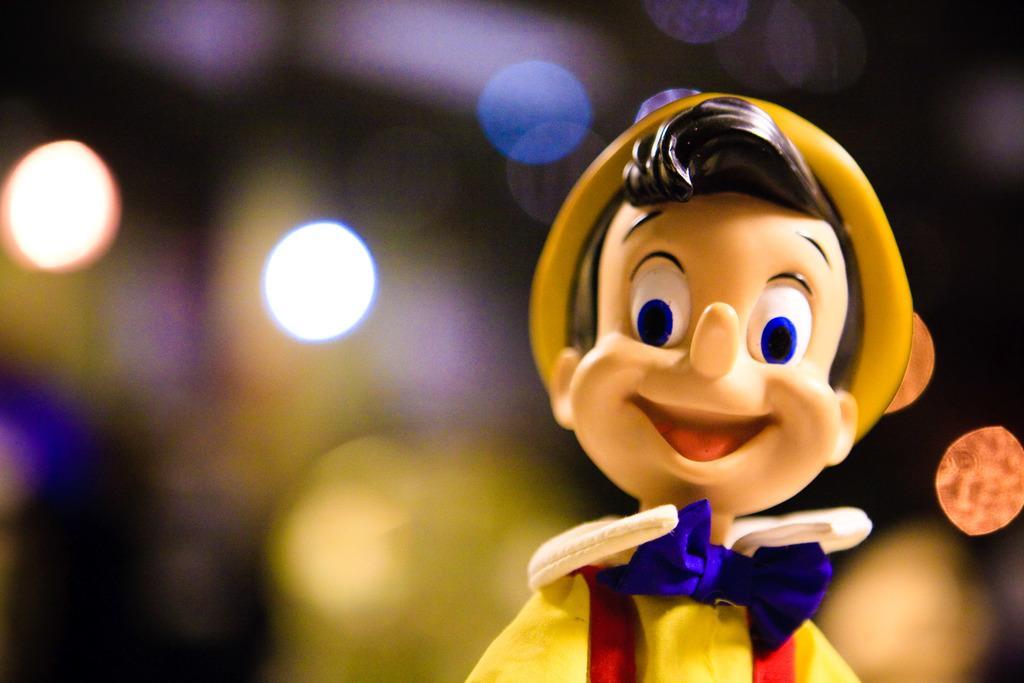Can you describe this image briefly? In this image, we can see a toy and in the background, there are lights. 